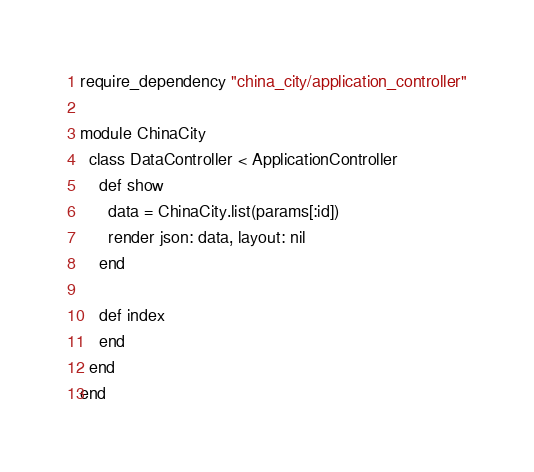Convert code to text. <code><loc_0><loc_0><loc_500><loc_500><_Ruby_>require_dependency "china_city/application_controller"

module ChinaCity
  class DataController < ApplicationController
    def show
      data = ChinaCity.list(params[:id])
      render json: data, layout: nil
    end

    def index
    end
  end
end
</code> 